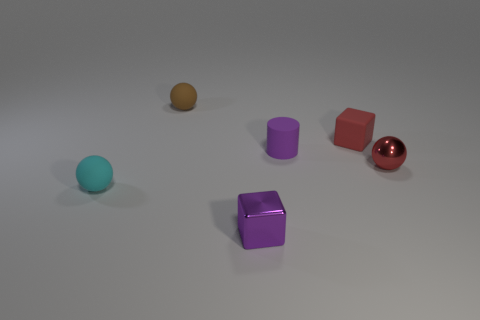Is the color of the matte cube the same as the metallic ball?
Offer a very short reply. Yes. Is the small brown object the same shape as the small purple rubber object?
Provide a short and direct response. No. How many other things are there of the same shape as the red shiny thing?
Ensure brevity in your answer.  2. What is the color of the cylinder that is the same size as the cyan rubber sphere?
Your answer should be very brief. Purple. Are there an equal number of tiny cyan matte objects that are behind the red metallic object and tiny blue objects?
Provide a short and direct response. Yes. What is the shape of the tiny rubber object that is both in front of the tiny red cube and to the right of the cyan ball?
Your response must be concise. Cylinder. Are there any other tiny cyan spheres made of the same material as the cyan sphere?
Your answer should be compact. No. There is a block that is the same color as the small rubber cylinder; what is its size?
Your response must be concise. Small. How many small things are behind the tiny metal block and on the right side of the brown sphere?
Give a very brief answer. 3. What is the thing behind the red matte block made of?
Offer a terse response. Rubber. 